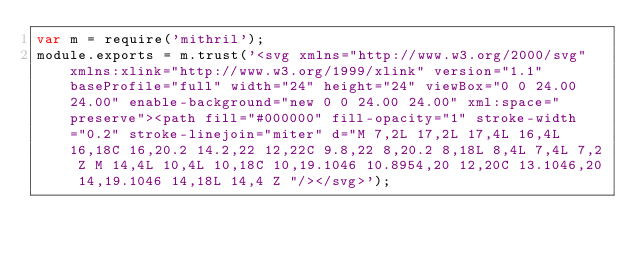Convert code to text. <code><loc_0><loc_0><loc_500><loc_500><_JavaScript_>var m = require('mithril');
module.exports = m.trust('<svg xmlns="http://www.w3.org/2000/svg" xmlns:xlink="http://www.w3.org/1999/xlink" version="1.1" baseProfile="full" width="24" height="24" viewBox="0 0 24.00 24.00" enable-background="new 0 0 24.00 24.00" xml:space="preserve"><path fill="#000000" fill-opacity="1" stroke-width="0.2" stroke-linejoin="miter" d="M 7,2L 17,2L 17,4L 16,4L 16,18C 16,20.2 14.2,22 12,22C 9.8,22 8,20.2 8,18L 8,4L 7,4L 7,2 Z M 14,4L 10,4L 10,18C 10,19.1046 10.8954,20 12,20C 13.1046,20 14,19.1046 14,18L 14,4 Z "/></svg>');
</code> 